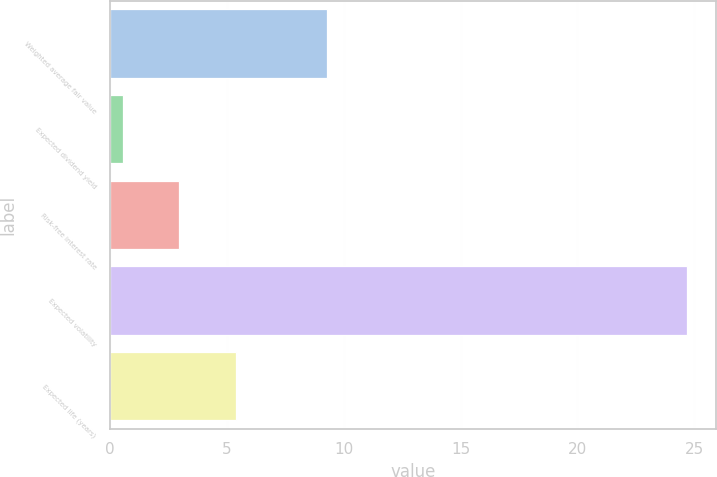Convert chart. <chart><loc_0><loc_0><loc_500><loc_500><bar_chart><fcel>Weighted average fair value<fcel>Expected dividend yield<fcel>Risk-free interest rate<fcel>Expected volatility<fcel>Expected life (years)<nl><fcel>9.3<fcel>0.53<fcel>2.95<fcel>24.7<fcel>5.37<nl></chart> 